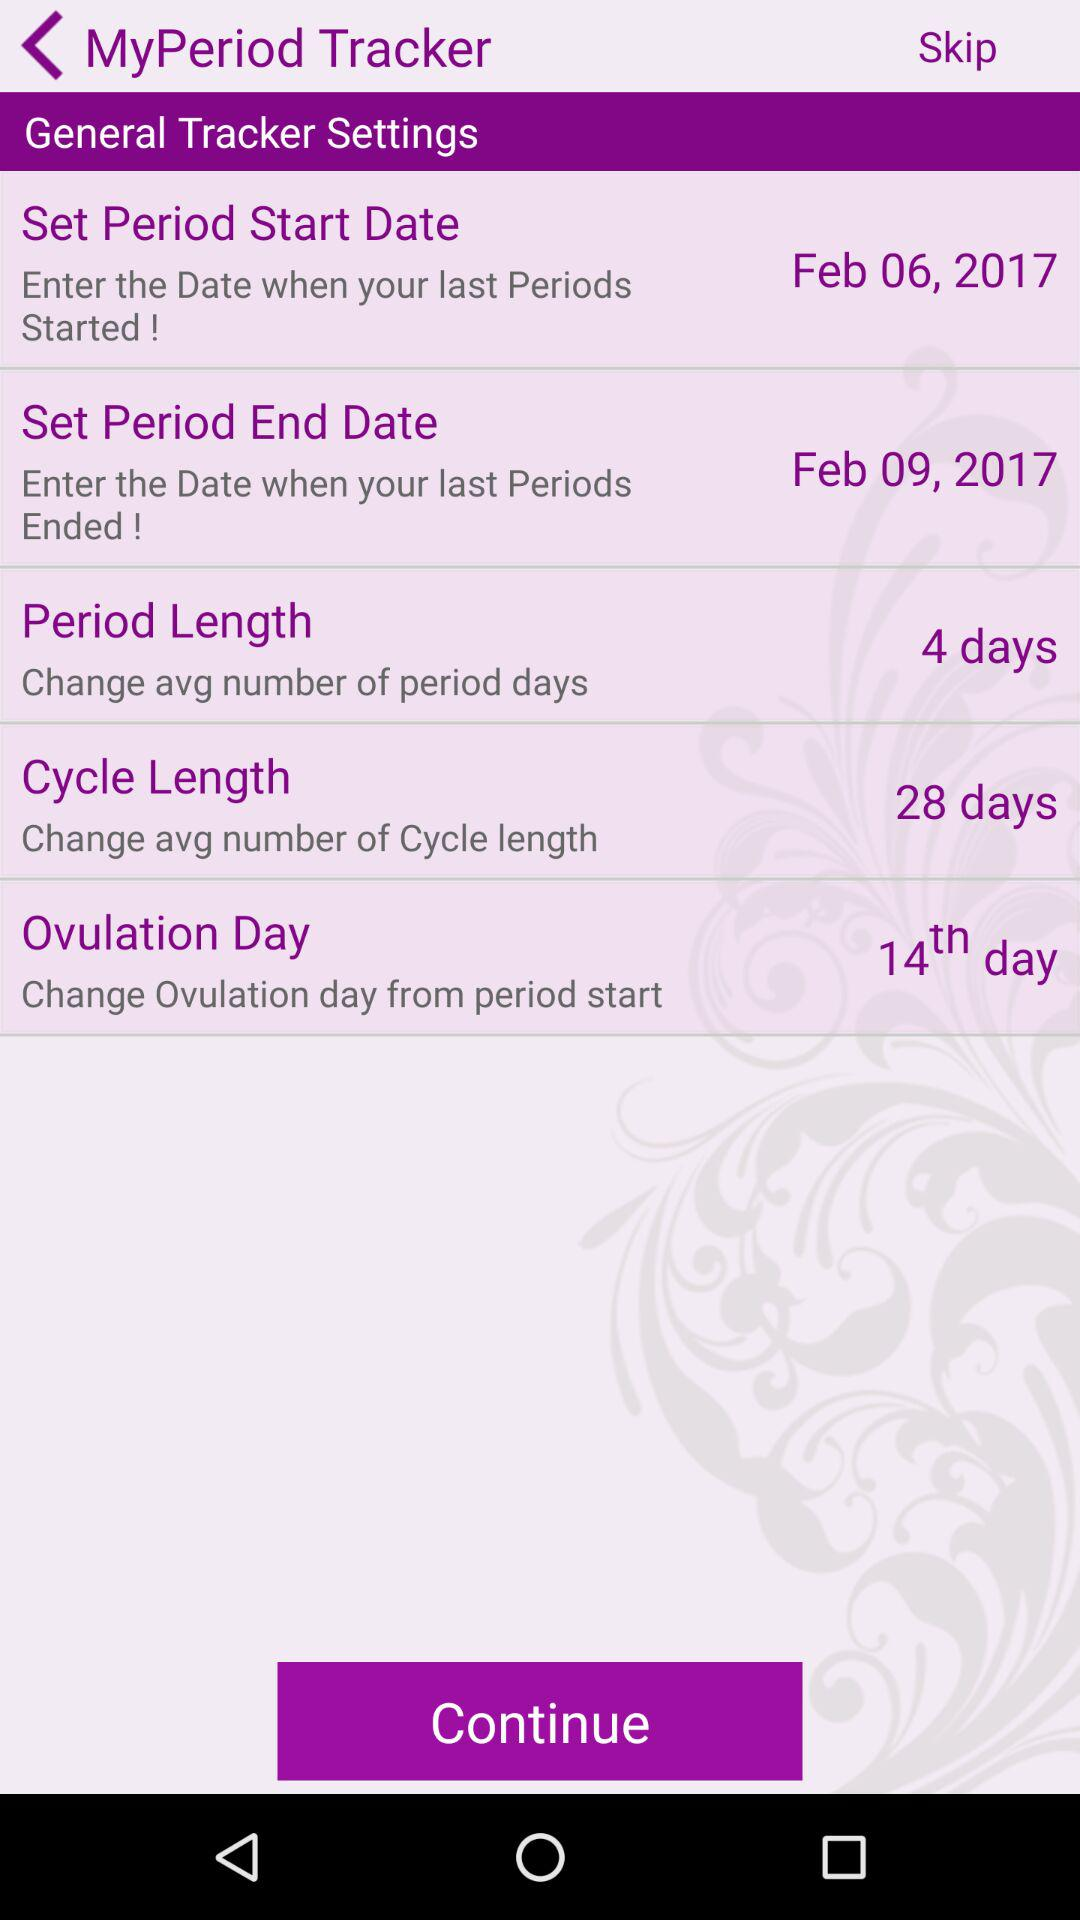How many more days are there in a cycle than in a period?
Answer the question using a single word or phrase. 24 